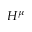Convert formula to latex. <formula><loc_0><loc_0><loc_500><loc_500>H ^ { \mu }</formula> 